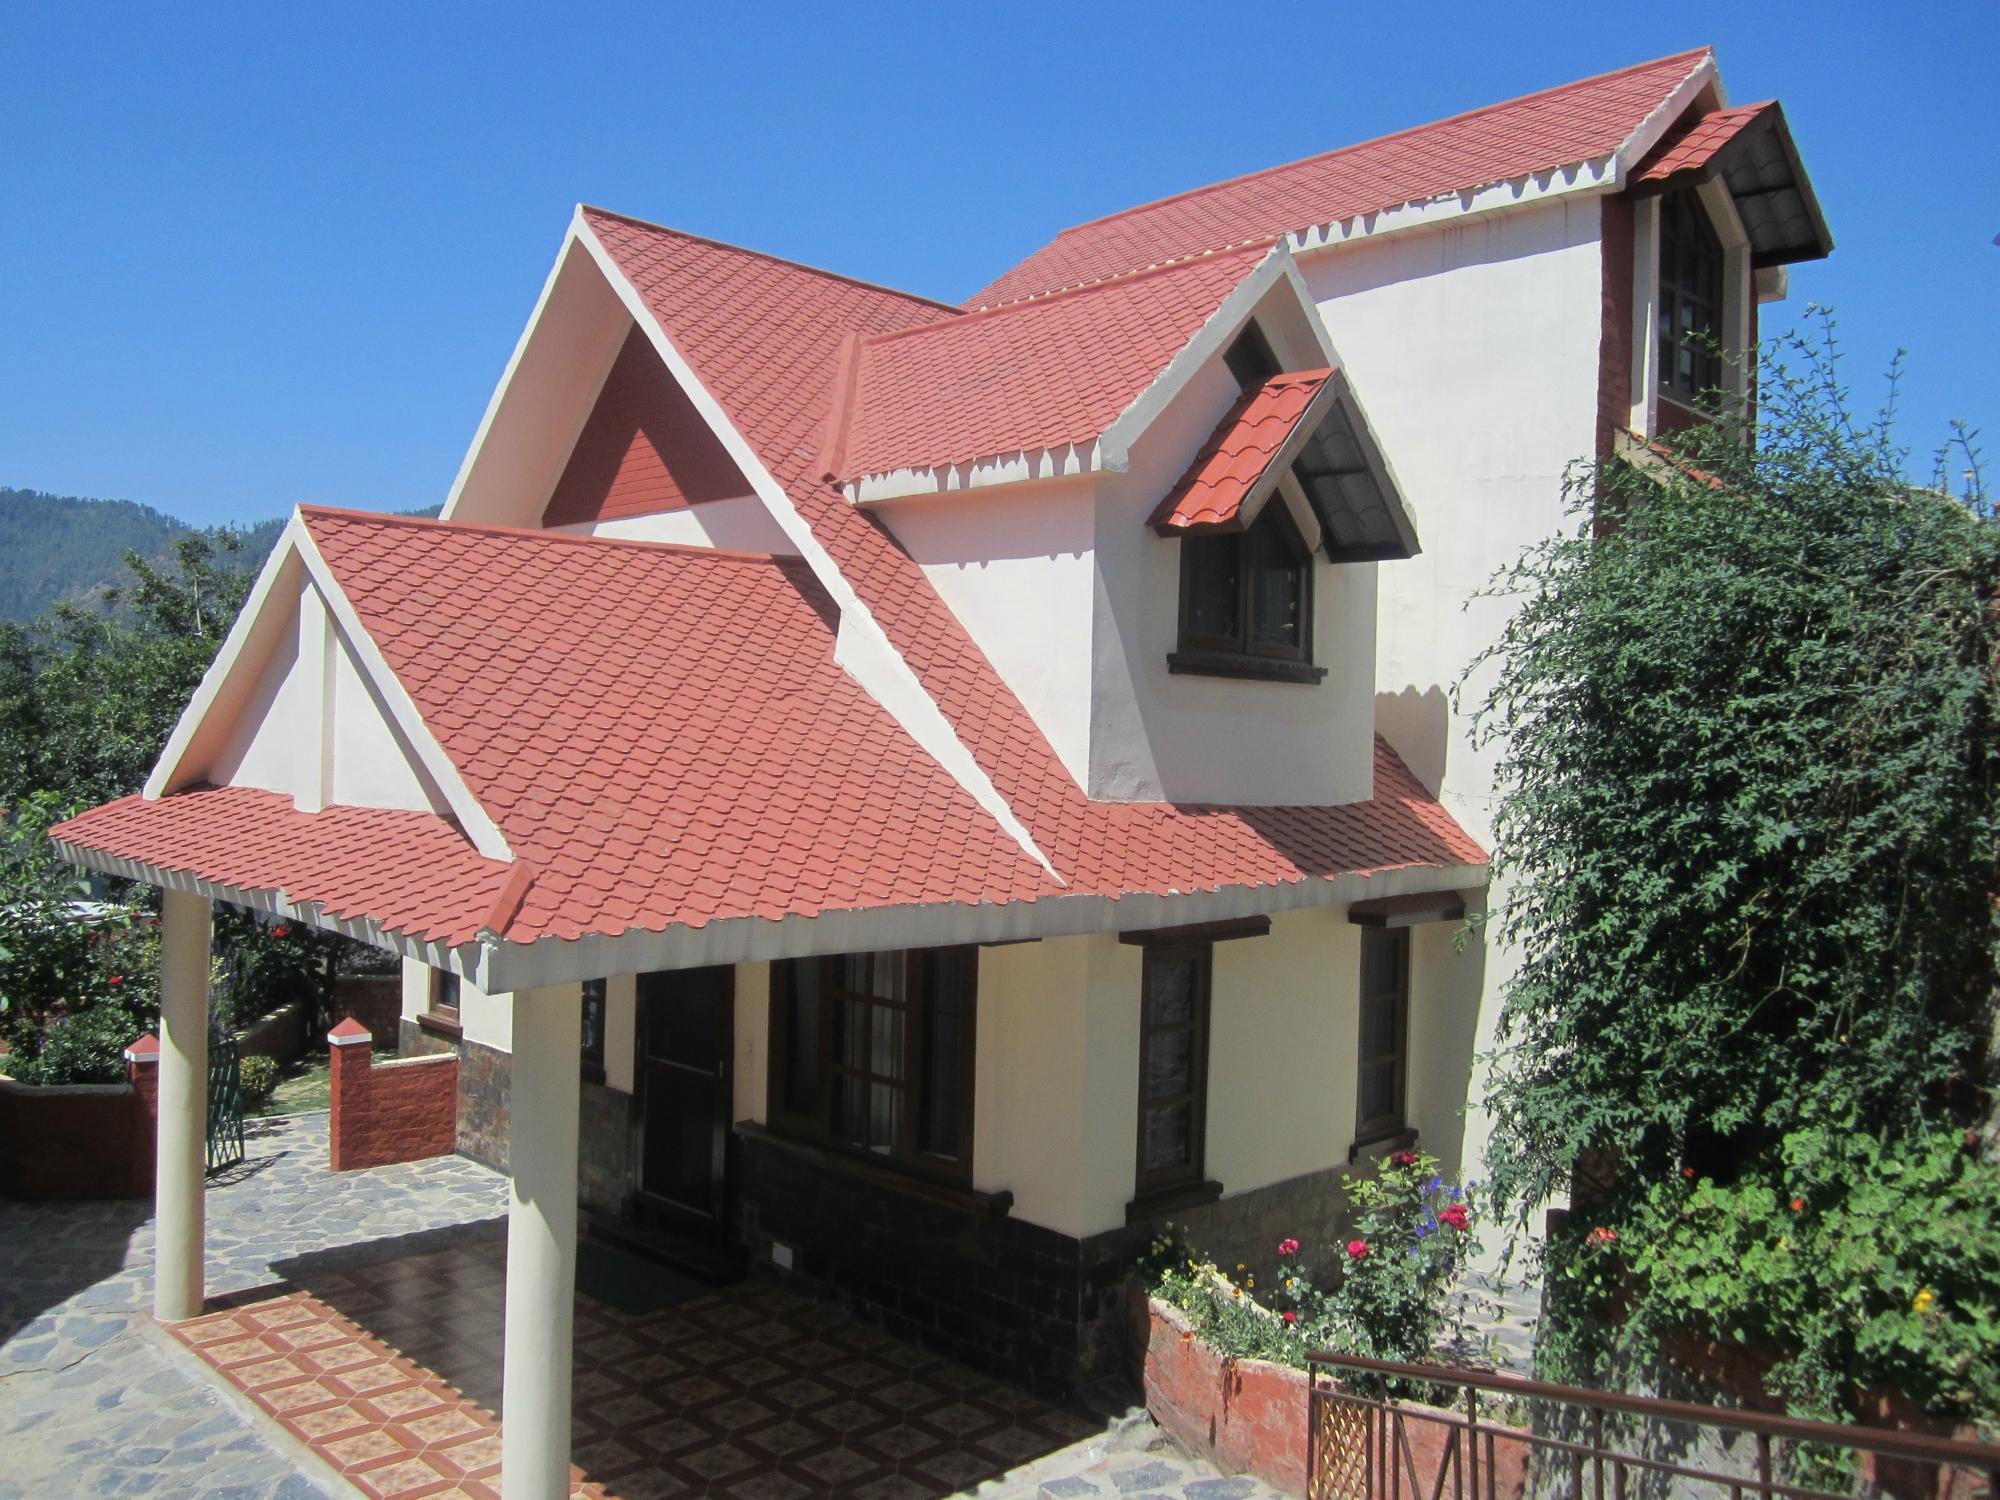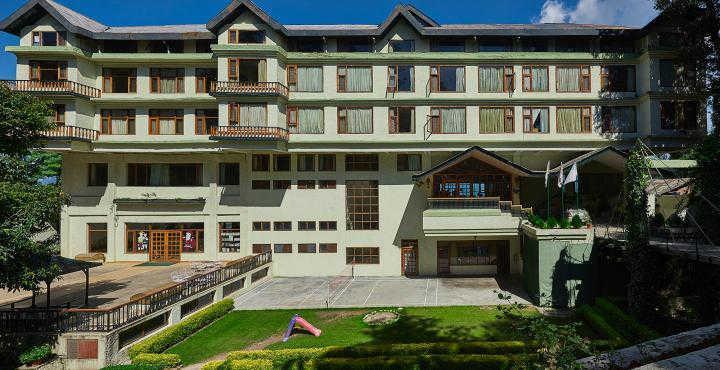The first image is the image on the left, the second image is the image on the right. For the images shown, is this caption "The roof is pink on the structure in the image on the left." true? Answer yes or no. Yes. 